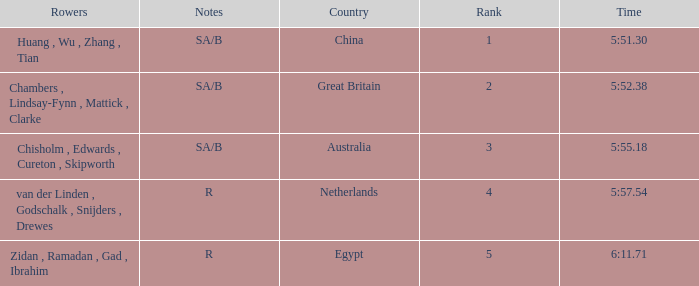What country has sa/b as the notes, and a time of 5:51.30? China. 